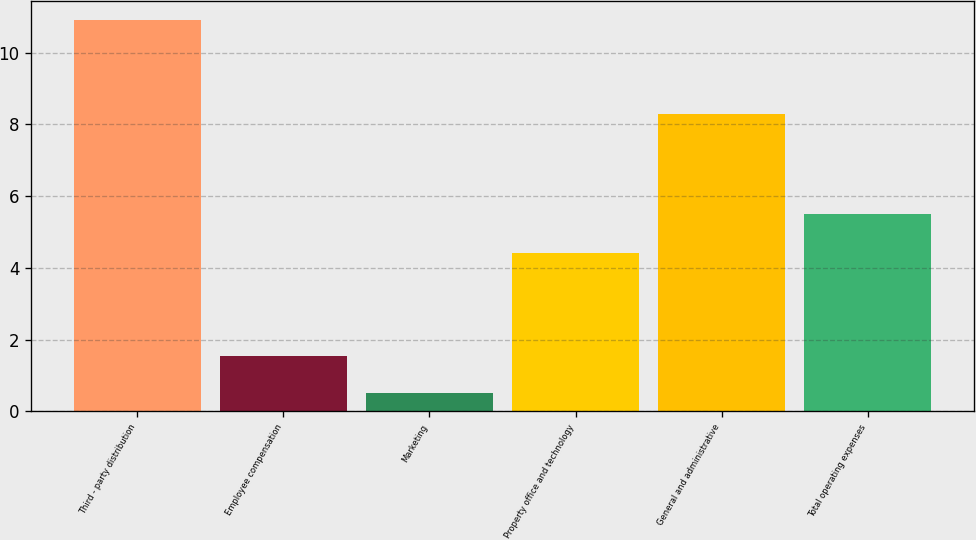Convert chart. <chart><loc_0><loc_0><loc_500><loc_500><bar_chart><fcel>Third - party distribution<fcel>Employee compensation<fcel>Marketing<fcel>Property office and technology<fcel>General and administrative<fcel>Total operating expenses<nl><fcel>10.9<fcel>1.54<fcel>0.5<fcel>4.4<fcel>8.3<fcel>5.5<nl></chart> 